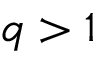Convert formula to latex. <formula><loc_0><loc_0><loc_500><loc_500>q > 1</formula> 